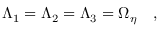<formula> <loc_0><loc_0><loc_500><loc_500>\Lambda _ { 1 } = \Lambda _ { 2 } = \Lambda _ { 3 } = \Omega _ { \eta } ,</formula> 